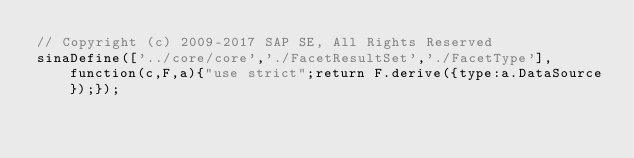Convert code to text. <code><loc_0><loc_0><loc_500><loc_500><_JavaScript_>// Copyright (c) 2009-2017 SAP SE, All Rights Reserved
sinaDefine(['../core/core','./FacetResultSet','./FacetType'],function(c,F,a){"use strict";return F.derive({type:a.DataSource});});
</code> 